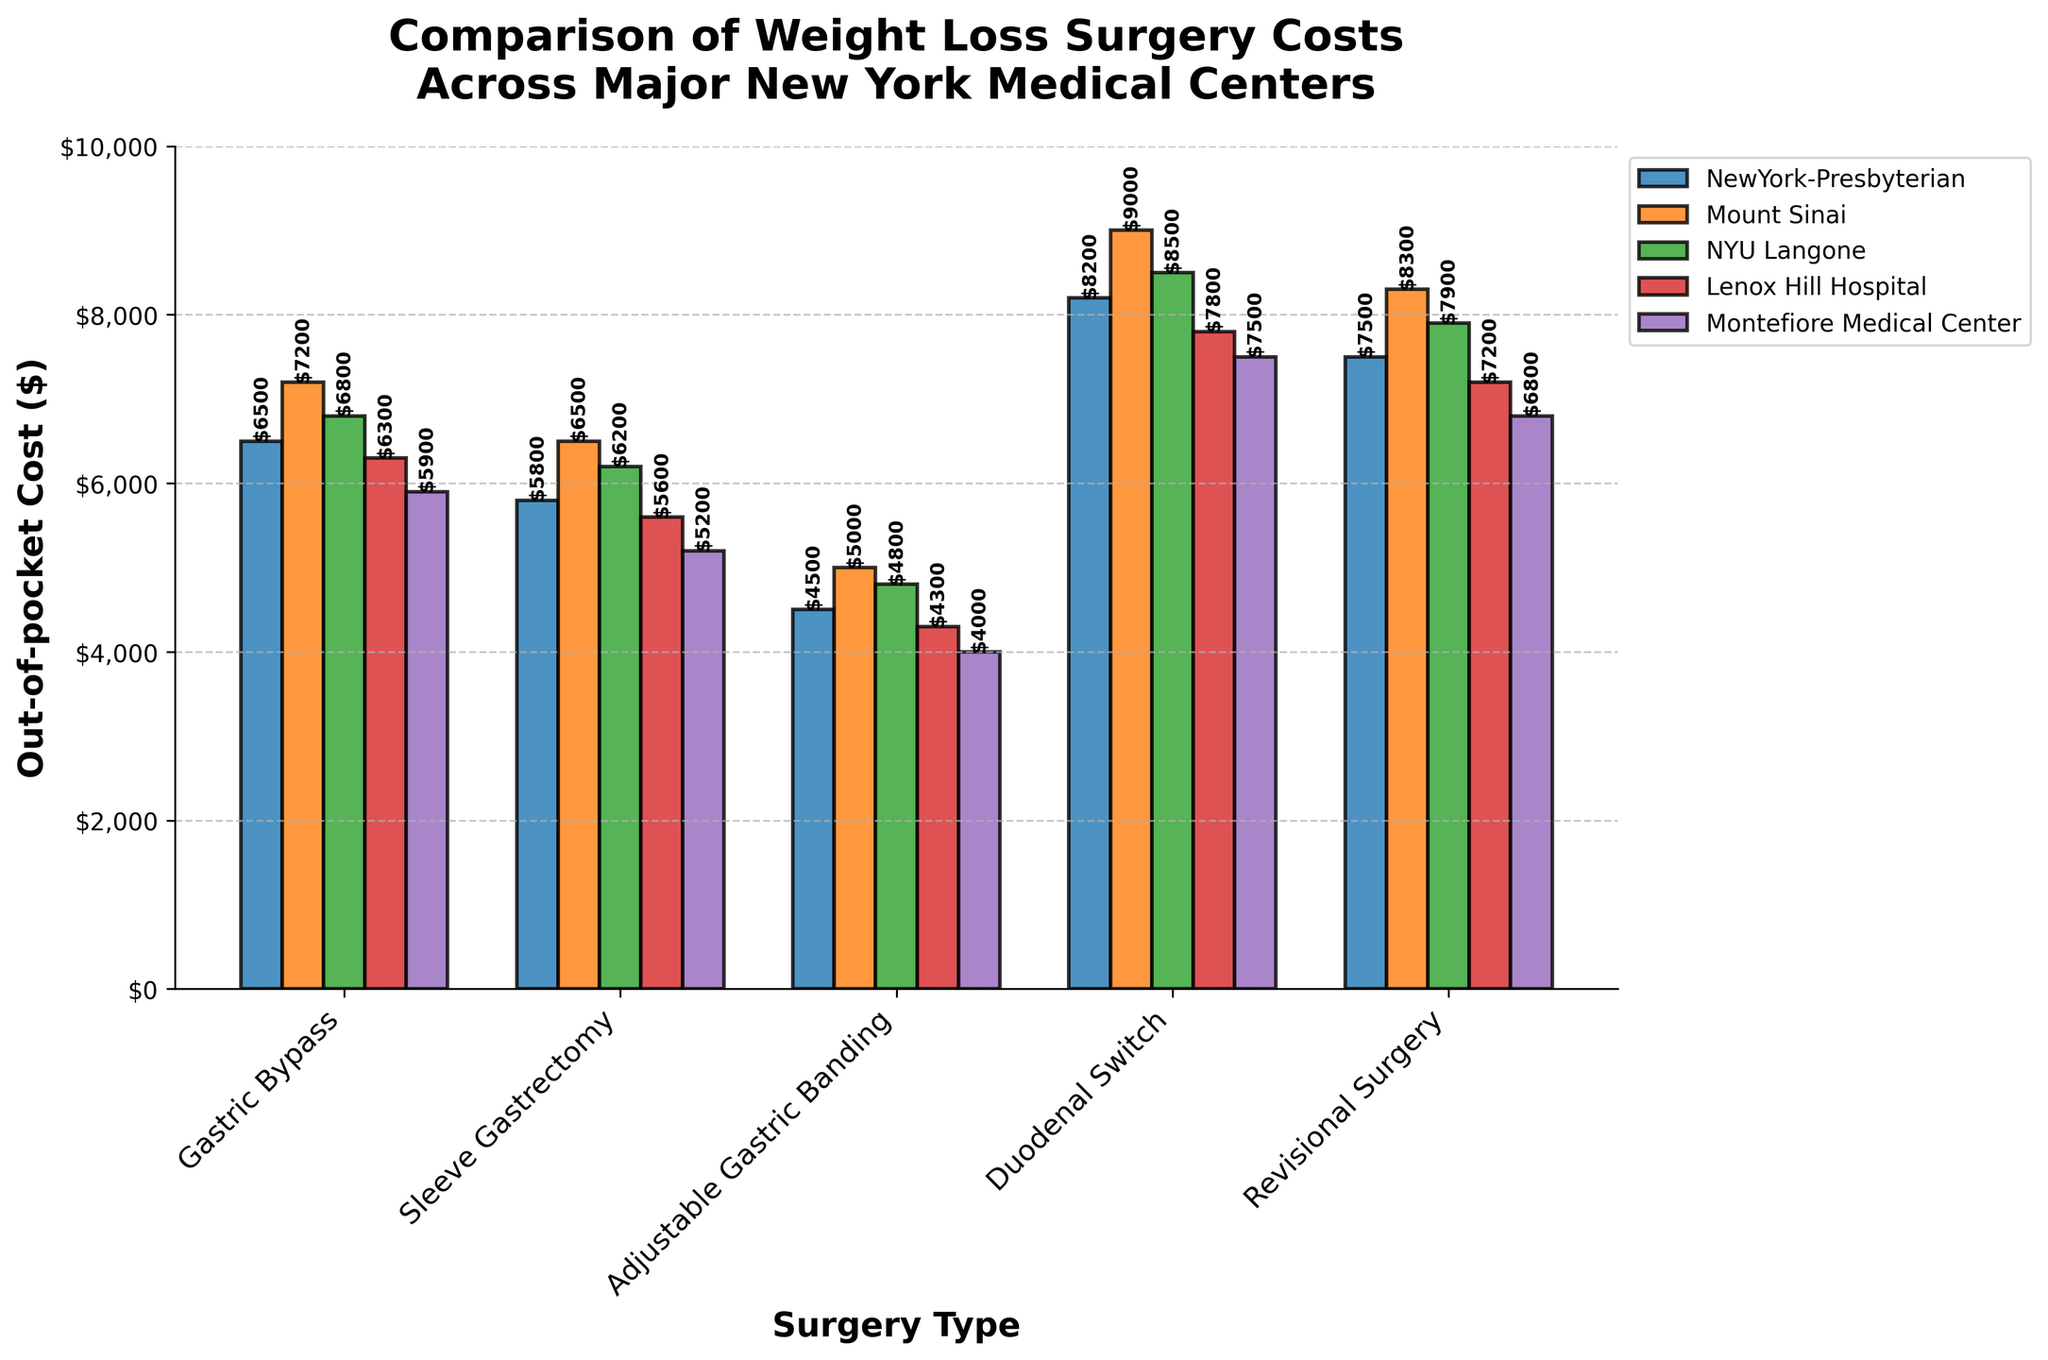Which hospital has the highest out-of-pocket cost for Duodenal Switch surgery? The highest bar in the Duodenal Switch category corresponds to Mount Sinai.
Answer: Mount Sinai How much more expensive is Gastric Bypass at Mount Sinai compared to Montefiore Medical Center? The cost at Mount Sinai is $7200, and at Montefiore Medical Center, it is $5900. The difference is $7200 - $5900.
Answer: $1300 What is the average cost of Sleeve Gastrectomy across all hospitals? Sum all the costs for Sleeve Gastrectomy: $5800 + $6500 + $6200 + $5600 + $5200 = $29300. There are 5 hospitals, so average = $29300 / 5.
Answer: $5860 Which hospital consistently has the lowest costs for all surgery types? Look for the hospital with the lowest bars across all categories: Montefiore Medical Center.
Answer: Montefiore Medical Center Is Sleeve Gastrectomy at NYU Langone more expensive than Adjustable Gastric Banding at Mount Sinai? Compare the heights of the bars: Sleeve Gastrectomy at NYU Langone is $6200, and Adjustable Gastric Banding at Mount Sinai is $5000. $6200 > $5000.
Answer: Yes What is the total out-of-pocket cost for undergoing Gastric Bypass at NewYork-Presbyterian and Sleeve Gastrectomy at Lenox Hill Hospital? Add the two costs: $6500 (NewYork-Presbyterian for Gastric Bypass) + $5600 (Lenox Hill Hospital for Sleeve Gastrectomy).
Answer: $12100 